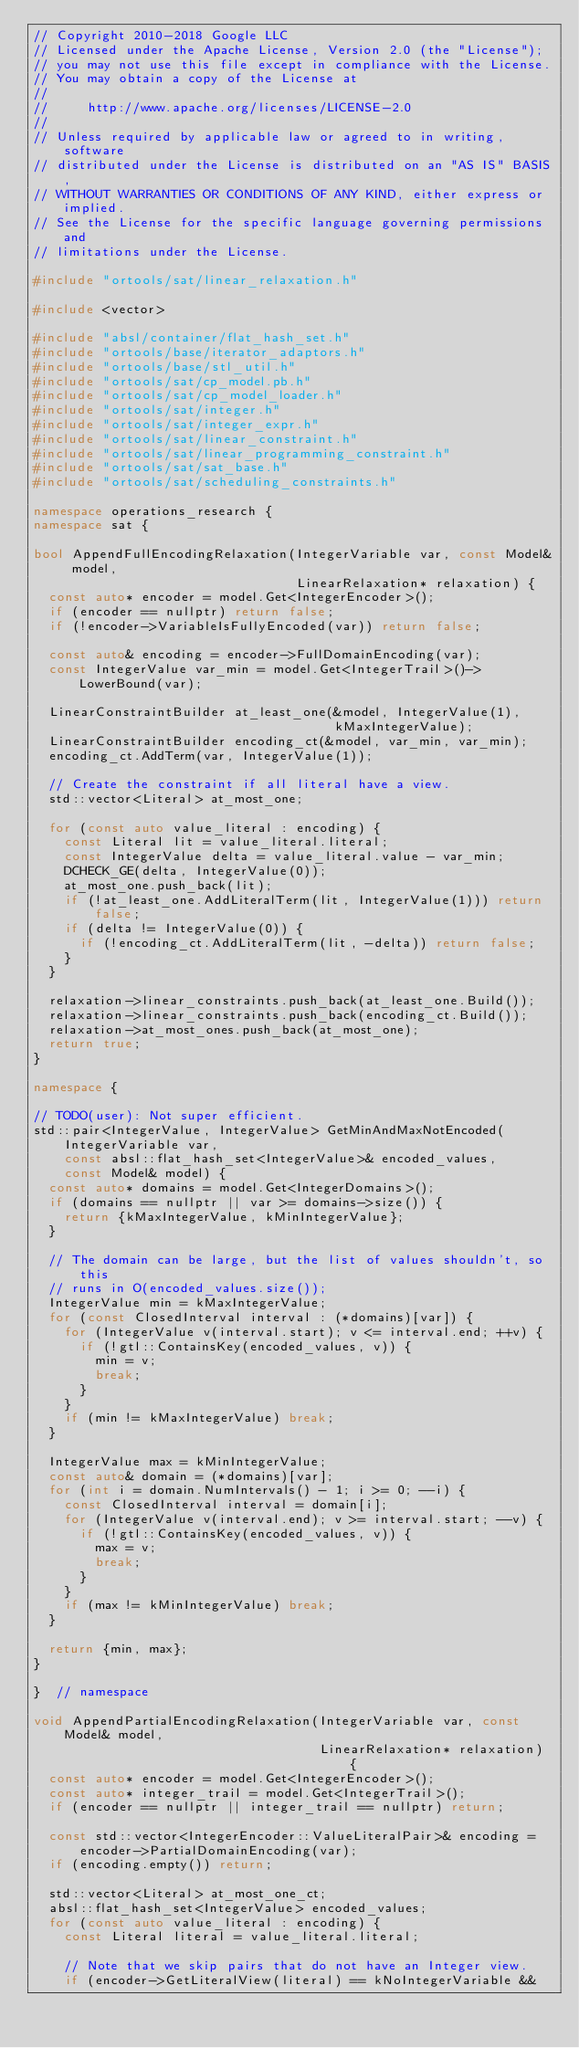Convert code to text. <code><loc_0><loc_0><loc_500><loc_500><_C++_>// Copyright 2010-2018 Google LLC
// Licensed under the Apache License, Version 2.0 (the "License");
// you may not use this file except in compliance with the License.
// You may obtain a copy of the License at
//
//     http://www.apache.org/licenses/LICENSE-2.0
//
// Unless required by applicable law or agreed to in writing, software
// distributed under the License is distributed on an "AS IS" BASIS,
// WITHOUT WARRANTIES OR CONDITIONS OF ANY KIND, either express or implied.
// See the License for the specific language governing permissions and
// limitations under the License.

#include "ortools/sat/linear_relaxation.h"

#include <vector>

#include "absl/container/flat_hash_set.h"
#include "ortools/base/iterator_adaptors.h"
#include "ortools/base/stl_util.h"
#include "ortools/sat/cp_model.pb.h"
#include "ortools/sat/cp_model_loader.h"
#include "ortools/sat/integer.h"
#include "ortools/sat/integer_expr.h"
#include "ortools/sat/linear_constraint.h"
#include "ortools/sat/linear_programming_constraint.h"
#include "ortools/sat/sat_base.h"
#include "ortools/sat/scheduling_constraints.h"

namespace operations_research {
namespace sat {

bool AppendFullEncodingRelaxation(IntegerVariable var, const Model& model,
                                  LinearRelaxation* relaxation) {
  const auto* encoder = model.Get<IntegerEncoder>();
  if (encoder == nullptr) return false;
  if (!encoder->VariableIsFullyEncoded(var)) return false;

  const auto& encoding = encoder->FullDomainEncoding(var);
  const IntegerValue var_min = model.Get<IntegerTrail>()->LowerBound(var);

  LinearConstraintBuilder at_least_one(&model, IntegerValue(1),
                                       kMaxIntegerValue);
  LinearConstraintBuilder encoding_ct(&model, var_min, var_min);
  encoding_ct.AddTerm(var, IntegerValue(1));

  // Create the constraint if all literal have a view.
  std::vector<Literal> at_most_one;

  for (const auto value_literal : encoding) {
    const Literal lit = value_literal.literal;
    const IntegerValue delta = value_literal.value - var_min;
    DCHECK_GE(delta, IntegerValue(0));
    at_most_one.push_back(lit);
    if (!at_least_one.AddLiteralTerm(lit, IntegerValue(1))) return false;
    if (delta != IntegerValue(0)) {
      if (!encoding_ct.AddLiteralTerm(lit, -delta)) return false;
    }
  }

  relaxation->linear_constraints.push_back(at_least_one.Build());
  relaxation->linear_constraints.push_back(encoding_ct.Build());
  relaxation->at_most_ones.push_back(at_most_one);
  return true;
}

namespace {

// TODO(user): Not super efficient.
std::pair<IntegerValue, IntegerValue> GetMinAndMaxNotEncoded(
    IntegerVariable var,
    const absl::flat_hash_set<IntegerValue>& encoded_values,
    const Model& model) {
  const auto* domains = model.Get<IntegerDomains>();
  if (domains == nullptr || var >= domains->size()) {
    return {kMaxIntegerValue, kMinIntegerValue};
  }

  // The domain can be large, but the list of values shouldn't, so this
  // runs in O(encoded_values.size());
  IntegerValue min = kMaxIntegerValue;
  for (const ClosedInterval interval : (*domains)[var]) {
    for (IntegerValue v(interval.start); v <= interval.end; ++v) {
      if (!gtl::ContainsKey(encoded_values, v)) {
        min = v;
        break;
      }
    }
    if (min != kMaxIntegerValue) break;
  }

  IntegerValue max = kMinIntegerValue;
  const auto& domain = (*domains)[var];
  for (int i = domain.NumIntervals() - 1; i >= 0; --i) {
    const ClosedInterval interval = domain[i];
    for (IntegerValue v(interval.end); v >= interval.start; --v) {
      if (!gtl::ContainsKey(encoded_values, v)) {
        max = v;
        break;
      }
    }
    if (max != kMinIntegerValue) break;
  }

  return {min, max};
}

}  // namespace

void AppendPartialEncodingRelaxation(IntegerVariable var, const Model& model,
                                     LinearRelaxation* relaxation) {
  const auto* encoder = model.Get<IntegerEncoder>();
  const auto* integer_trail = model.Get<IntegerTrail>();
  if (encoder == nullptr || integer_trail == nullptr) return;

  const std::vector<IntegerEncoder::ValueLiteralPair>& encoding =
      encoder->PartialDomainEncoding(var);
  if (encoding.empty()) return;

  std::vector<Literal> at_most_one_ct;
  absl::flat_hash_set<IntegerValue> encoded_values;
  for (const auto value_literal : encoding) {
    const Literal literal = value_literal.literal;

    // Note that we skip pairs that do not have an Integer view.
    if (encoder->GetLiteralView(literal) == kNoIntegerVariable &&</code> 